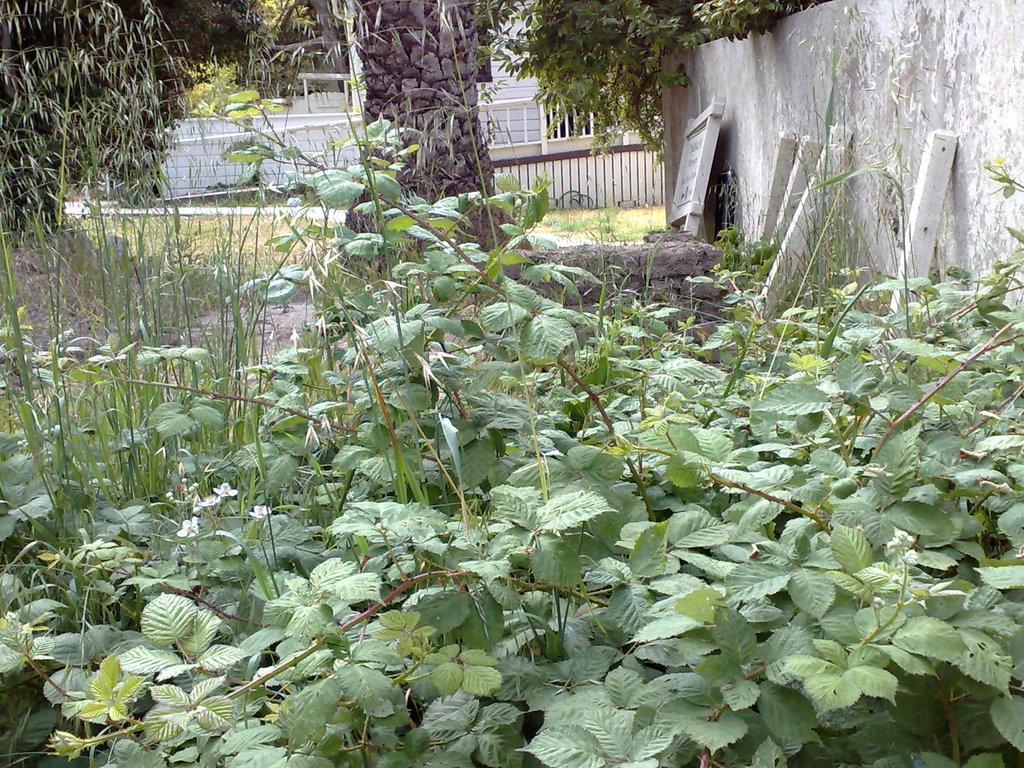What is depicted on the path in the image? There are planets on the path in the image. What type of natural elements can be seen in the image? There are plants in the image. What is the arrangement of the plants and the wall in the image? There is a wall in front of the plants. What structure is located in front of the wall in the image? There is a house in front of the wall in the image. Can you see a stranger looking at the house in the image? There is no stranger present in the image. Are there any cactus plants visible in the image? There is no mention of cactus plants in the provided facts, and therefore we cannot determine their presence in the image. 